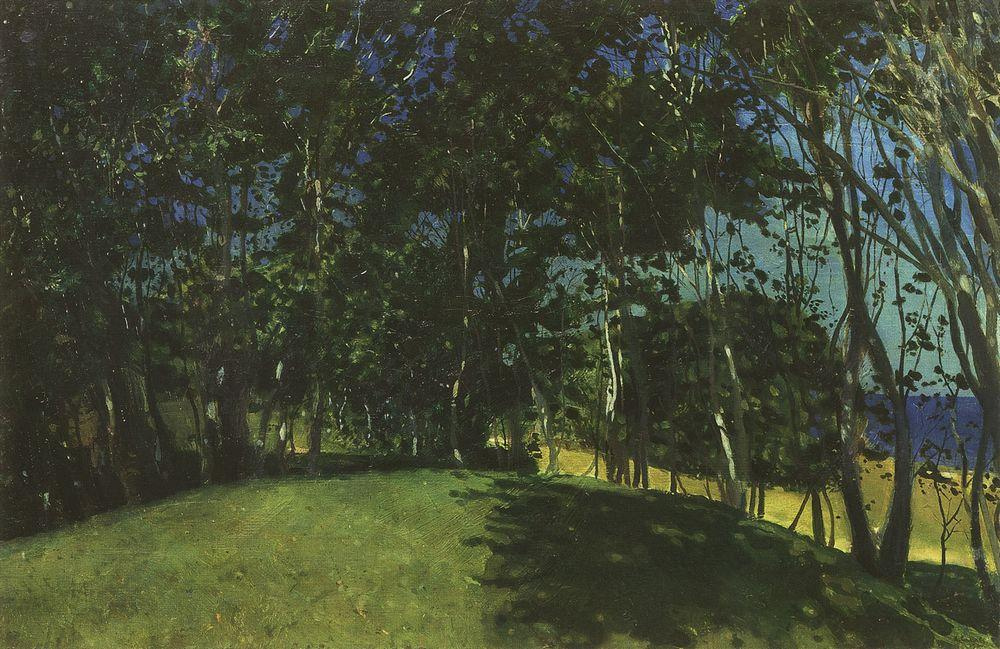What time of day does this painting likely represent? The shadows are long and the quality of light is soft yet vivid, which typically suggests late afternoon or early evening. This time of day is often chosen by artists on account of the 'golden hour', where the sunlight is warmer and more diffused, enhancing the natural colors of the landscape. 